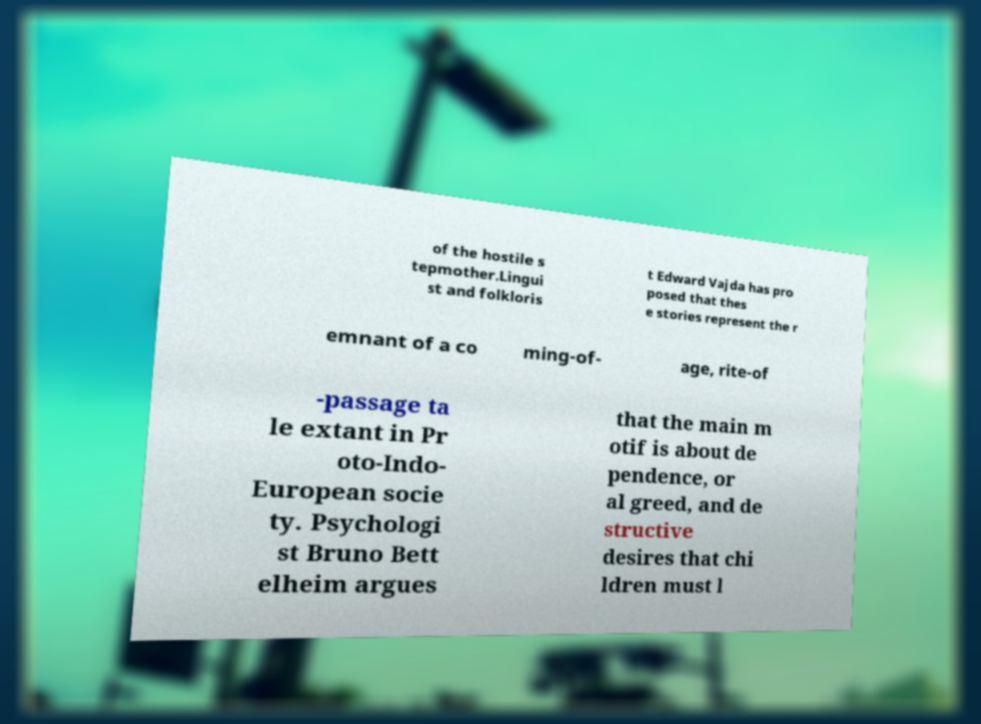Please identify and transcribe the text found in this image. of the hostile s tepmother.Lingui st and folkloris t Edward Vajda has pro posed that thes e stories represent the r emnant of a co ming-of- age, rite-of -passage ta le extant in Pr oto-Indo- European socie ty. Psychologi st Bruno Bett elheim argues that the main m otif is about de pendence, or al greed, and de structive desires that chi ldren must l 